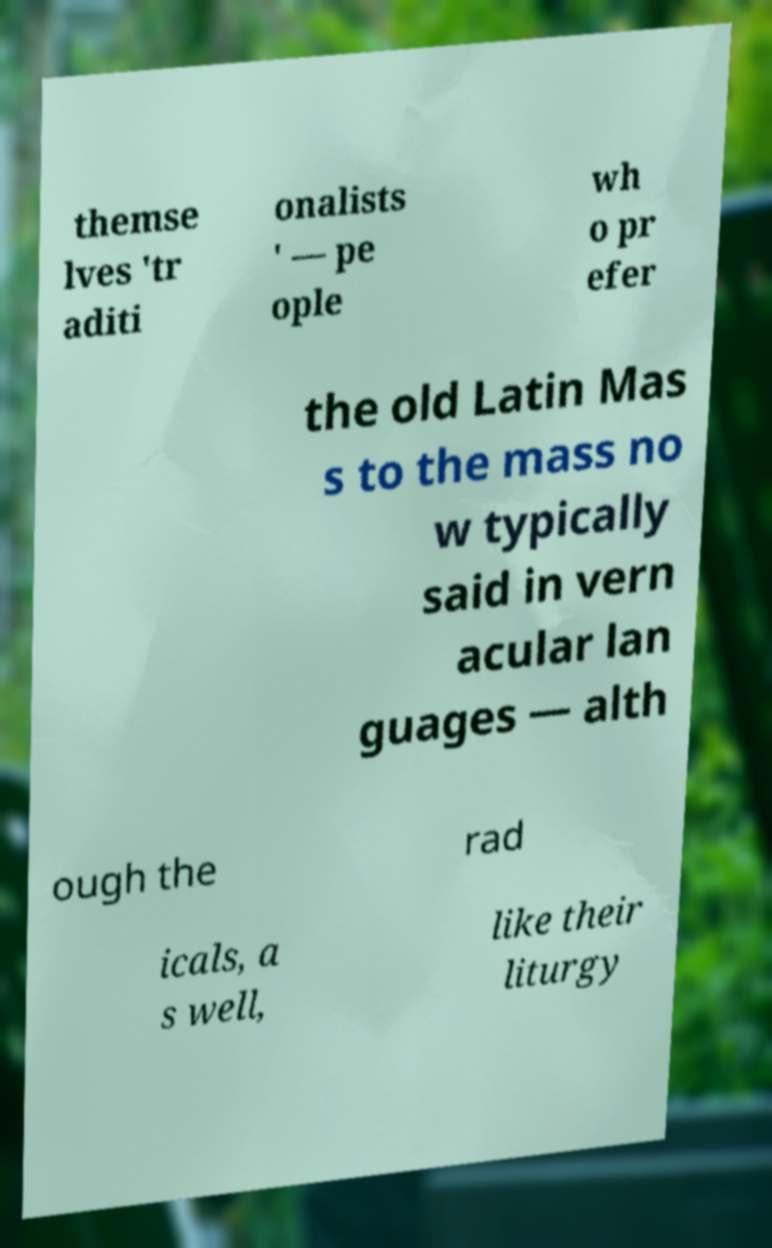Please read and relay the text visible in this image. What does it say? themse lves 'tr aditi onalists ' — pe ople wh o pr efer the old Latin Mas s to the mass no w typically said in vern acular lan guages — alth ough the rad icals, a s well, like their liturgy 